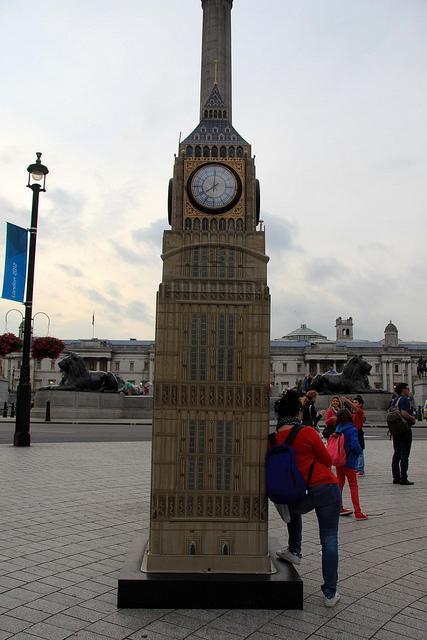What public service does the structure seen here serve?
Choose the right answer and clarify with the format: 'Answer: answer
Rationale: rationale.'
Options: Time keeping, security, policing, cleaning. Answer: time keeping.
Rationale: It tells the time. 